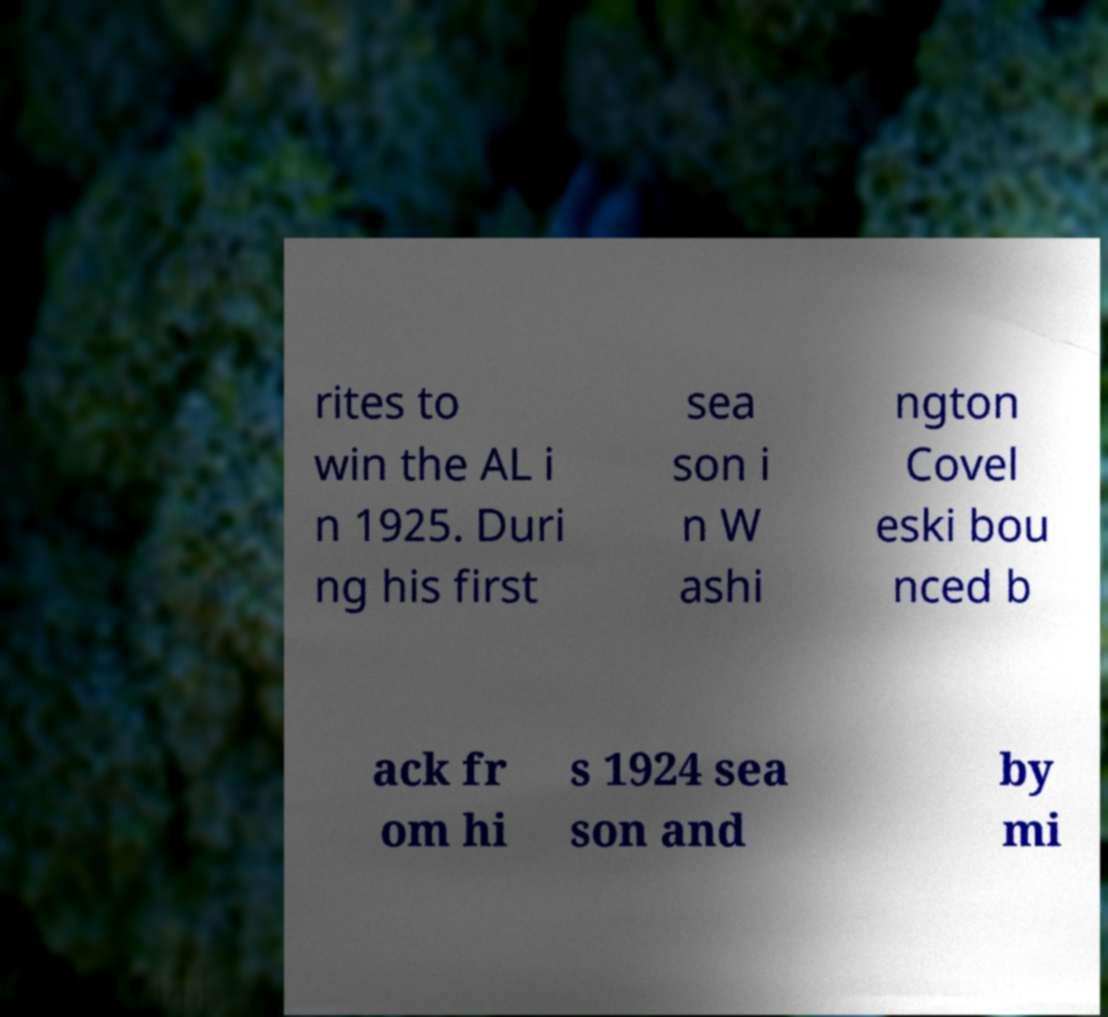Please read and relay the text visible in this image. What does it say? rites to win the AL i n 1925. Duri ng his first sea son i n W ashi ngton Covel eski bou nced b ack fr om hi s 1924 sea son and by mi 